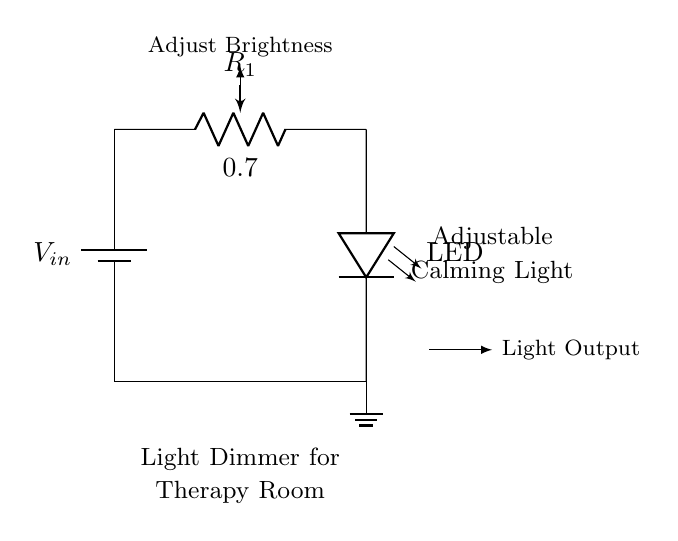What is the input voltage of this circuit? The circuit includes a battery symbol labeled V_in, which represents the source of input voltage. The value of this voltage can vary but is typically a DC voltage from a battery.
Answer: V_in What component is used to adjust the brightness of the light? The circuit diagram shows a potentiometer labeled R_1, which regulates the current flowing to the LED, thereby controlling its brightness.
Answer: Potentiometer What is the role of the LED in this circuit? The LED is connected in series with the potentiometer, allowing it to emit light when current flows through it. The brightness can be adjusted by modifying the resistance of R_1.
Answer: Emit light How does adjusting the potentiometer affect the output light? Adjusting the potentiometer changes the resistance in the circuit, which alters the voltage drop across the LED. A lower resistance allows more current to flow, increasing brightness, while higher resistance reduces it.
Answer: Changes brightness Which two components define the voltage divider in this circuit? The voltage divider in this circuit is created by the series connection of the potentiometer (R_1) and the LED. The voltage drop is divided between these components based on their resistances.
Answer: Potentiometer and LED 